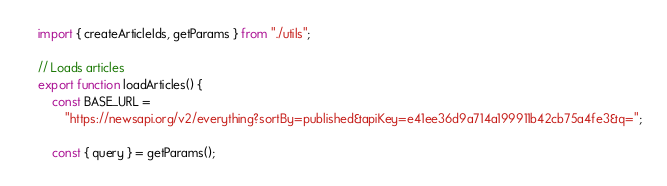Convert code to text. <code><loc_0><loc_0><loc_500><loc_500><_JavaScript_>import { createArticleIds, getParams } from "./utils";

// Loads articles
export function loadArticles() {
    const BASE_URL =
        "https://newsapi.org/v2/everything?sortBy=published&apiKey=e41ee36d9a714a199911b42cb75a4fe3&q=";

    const { query } = getParams();</code> 